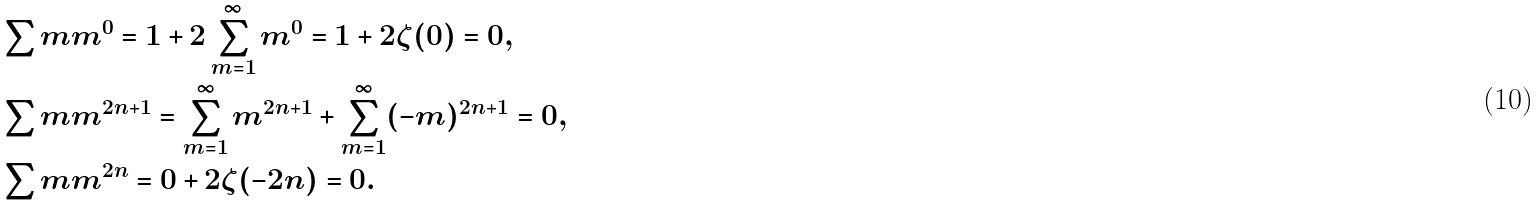Convert formula to latex. <formula><loc_0><loc_0><loc_500><loc_500>& \sum m m ^ { 0 } = 1 + 2 \sum _ { m = 1 } ^ { \infty } m ^ { 0 } = 1 + 2 \zeta ( 0 ) = 0 , \\ & \sum m m ^ { 2 n + 1 } = \sum _ { m = 1 } ^ { \infty } m ^ { 2 n + 1 } + \sum _ { m = 1 } ^ { \infty } ( - m ) ^ { 2 n + 1 } = 0 , \\ & \sum m m ^ { 2 n } = 0 + 2 \zeta ( - 2 n ) = 0 .</formula> 